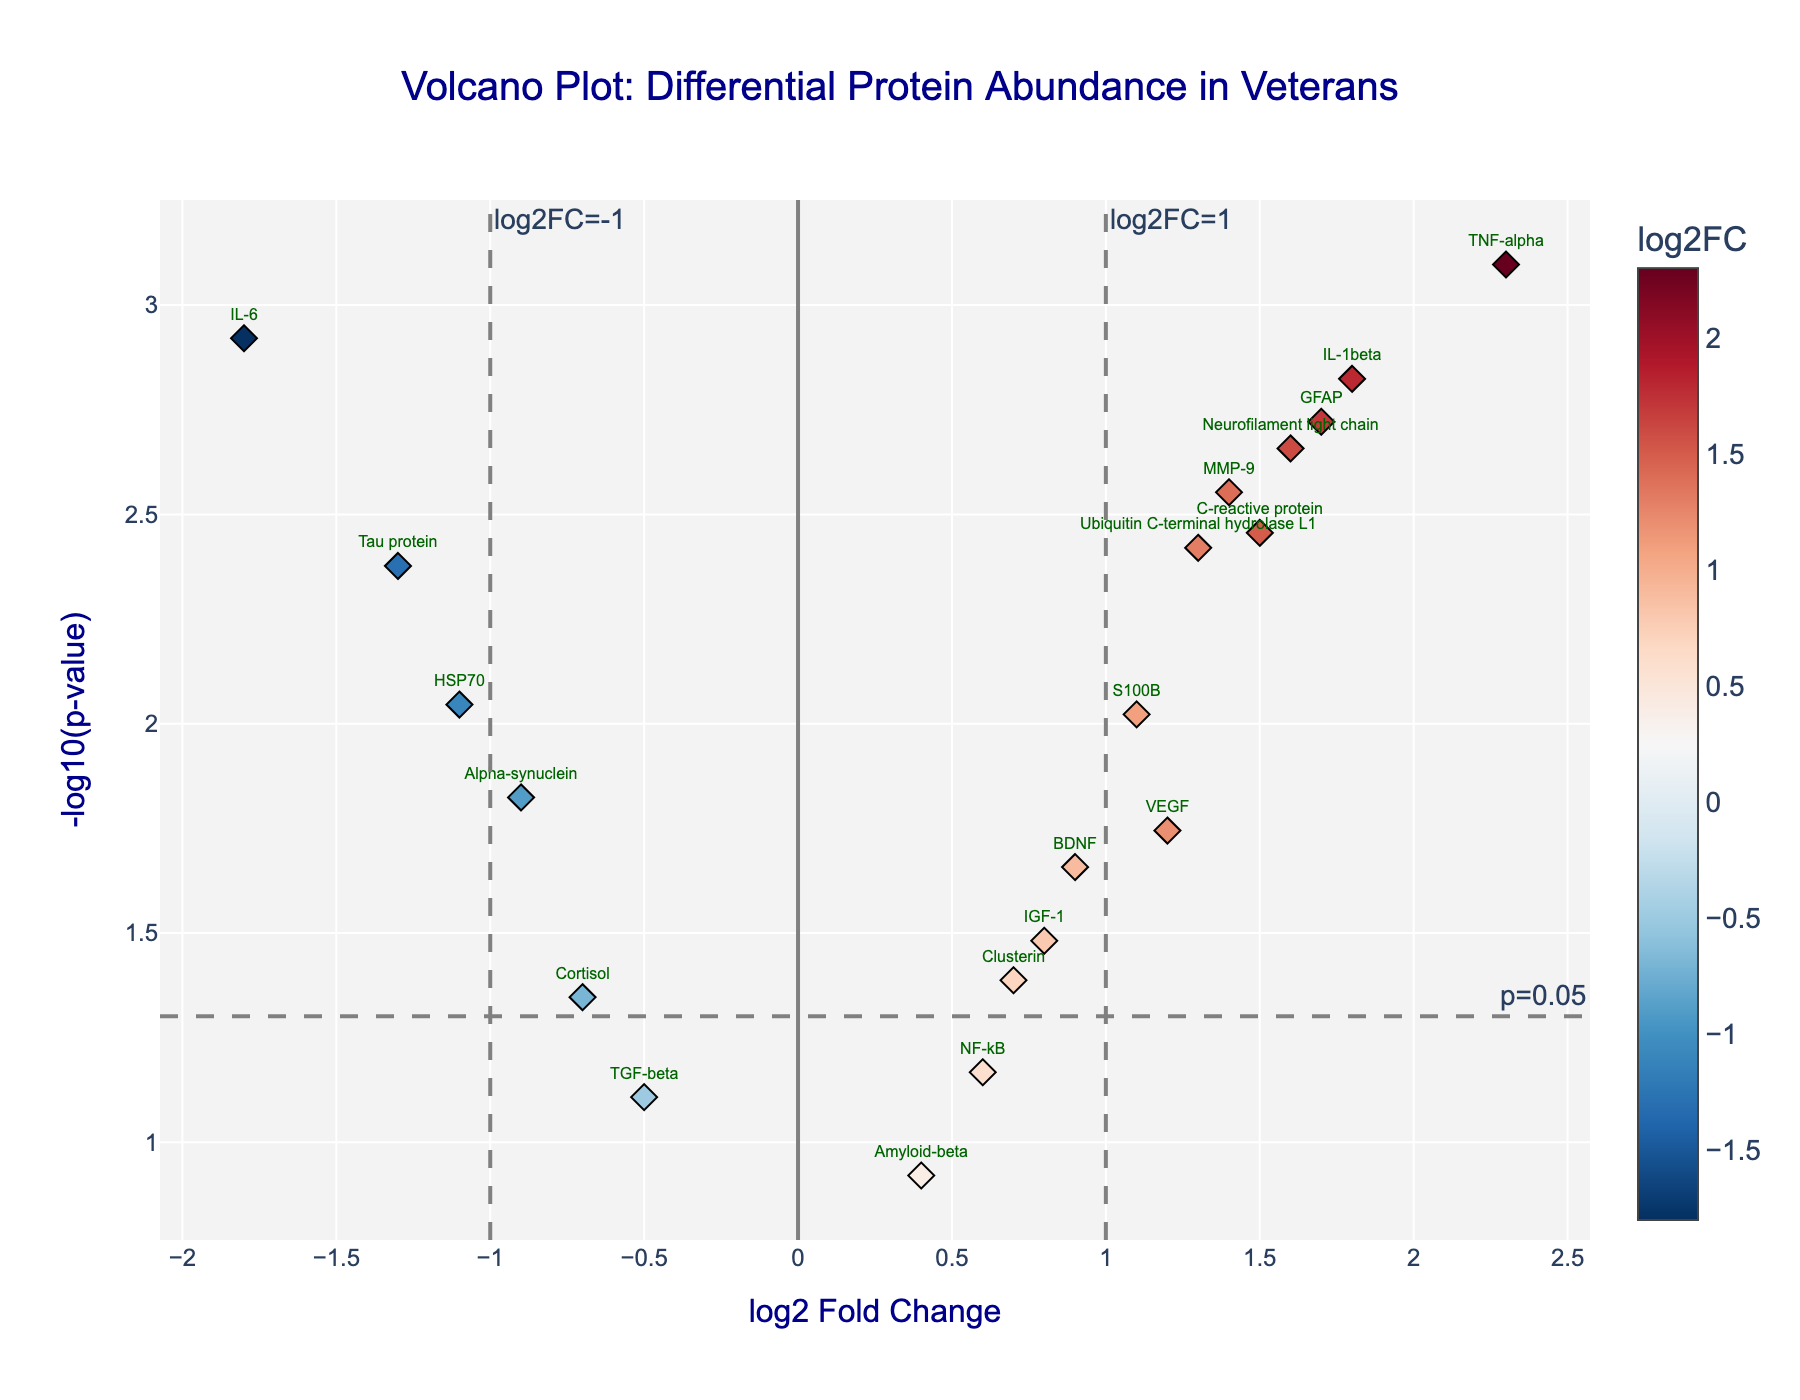What is the title of the figure? The title is usually located at the top of the figure and should describe what the figure is about.
Answer: Volcano Plot: Differential Protein Abundance in Veterans At what p-value are the threshold lines drawn? The horizontal threshold line corresponds to a p-value of 0.05, which is indicated in the figure annotation near the dashed line at y = -log10(0.05).
Answer: 0.05 Which protein has the highest log2 Fold Change? The log2 Fold Change values can be compared to identify the highest value. TNF-alpha has the highest log2 fold change at 2.3.
Answer: TNF-alpha Which protein has the lowest log2 Fold Change? The log2 Fold Change values can be compared to identify the lowest value. IL-6 has the lowest log2 Fold Change at -1.8.
Answer: IL-6 How many proteins have a p-value less than 0.05? The p-value threshold line at 0.05 helps identify which proteins have significant p-values. Count the number of data points above this line. There are 15 such proteins.
Answer: 15 What are the log2 Fold Change and -log10(p-value) for IL-1beta? By hovering over or finding the label for IL-1beta, one can read off the log2 Fold Change and -log10(p-value) values from the plot. The values are 1.8 and -log10(0.0015).
Answer: 1.8, 2.82 Which proteins are downregulated (negative log2 Fold Change) and significant (p-value < 0.05)? Downregulated proteins will have a negative log2 Fold Change value, and significant proteins will be above the p-value threshold line. The proteins are IL-6, HSP70, and Tau protein.
Answer: IL-6, HSP70, Tau protein Which protein has the highest -log10(p-value)? The highest -log10(p-value) indicates the most significant change. TNF-alpha has the highest value with -log10(0.0008).
Answer: TNF-alpha What is the range of log2 Fold Change values in this sample? The range of log2 Fold Change is determined by finding the minimum and maximum values. The range is from -1.8 to 2.3.
Answer: -1.8 to 2.3 Compare the log2 Fold Change of Cortisol and Amyloid-beta. Which is greater? Identify the log2 Fold Change for each protein from the figure. Cortisol has a log2 Fold Change of -0.7, while Amyloid-beta has 0.4. Therefore, Amyloid-beta’s is greater.
Answer: Amyloid-beta 